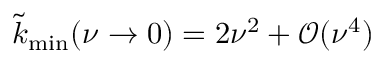Convert formula to latex. <formula><loc_0><loc_0><loc_500><loc_500>\tilde { k } _ { \min } ( \nu \rightarrow 0 ) = 2 \nu ^ { 2 } + \mathcal { O } ( \nu ^ { 4 } )</formula> 